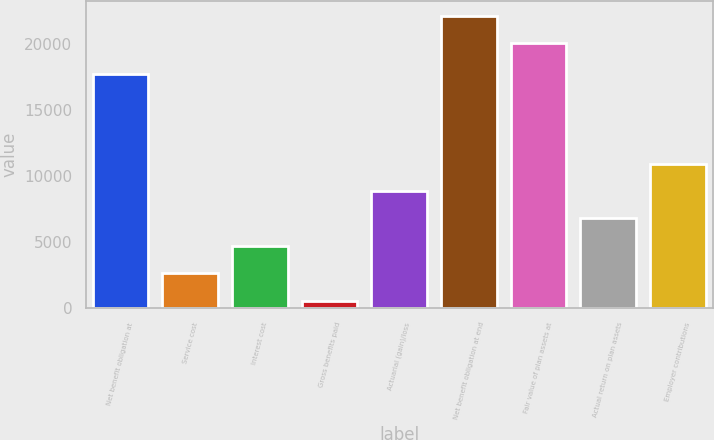Convert chart. <chart><loc_0><loc_0><loc_500><loc_500><bar_chart><fcel>Net benefit obligation at<fcel>Service cost<fcel>Interest cost<fcel>Gross benefits paid<fcel>Actuarial (gain)/loss<fcel>Net benefit obligation at end<fcel>Fair value of plan assets at<fcel>Actual return on plan assets<fcel>Employer contributions<nl><fcel>17763<fcel>2650.8<fcel>4727.6<fcel>574<fcel>8881.2<fcel>22168.8<fcel>20092<fcel>6804.4<fcel>10958<nl></chart> 